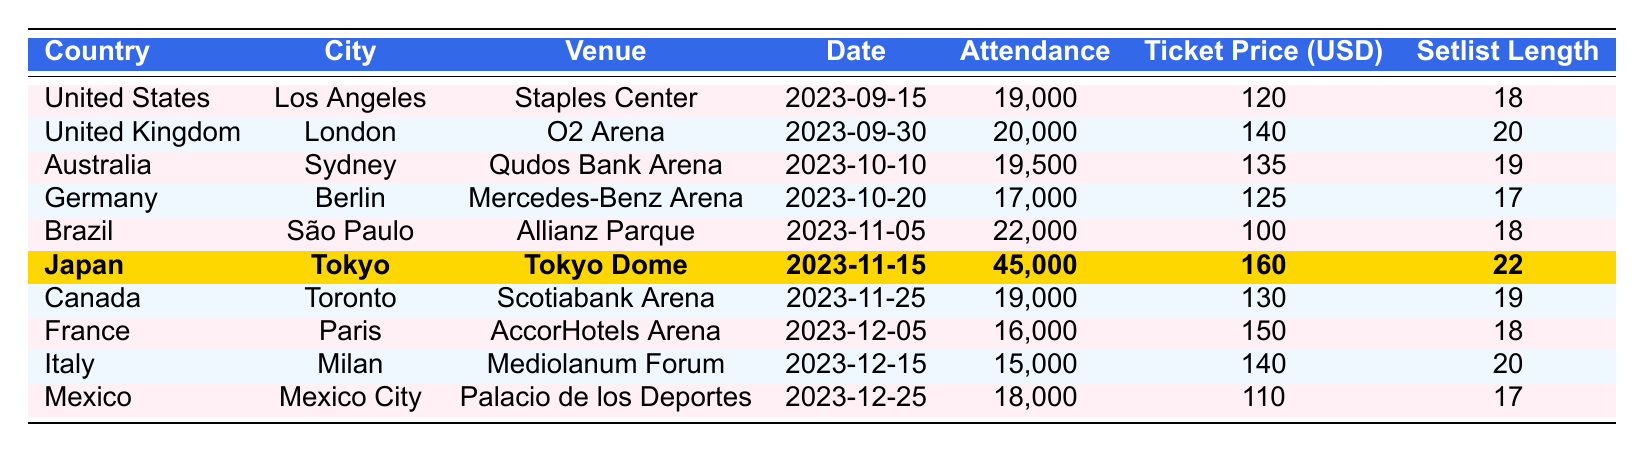What is the highest concert attendance for the Red Hot Chili Peppers tour? The table indicates that the highest attendance is from Japan at the Tokyo Dome with 45,000 attendees.
Answer: 45,000 What city in Canada hosted a Red Hot Chili Peppers concert? According to the table, the concert in Canada was held in Toronto.
Answer: Toronto How much was the ticket price in Brazil? The table shows that the ticket price in Brazil for the concert in São Paulo was 100 USD.
Answer: 100 Which country had the lowest concert attendance? By reviewing the attendance figures, France had the lowest with 16,000 attendees at the concert in Paris.
Answer: France What was the average ticket price for concerts in the United States and Canada? The ticket prices in the U.S. (120 USD) and Canada (130 USD) sum to 250 USD. Dividing by 2 gives an average ticket price of 125 USD.
Answer: 125 Did Japan's concert have the longest setlist? The table shows Japan with a setlist length of 22, which is the longest compared to other countries listed.
Answer: Yes What is the total attendance of all concerts held in countries with ticket prices above 130 USD? The countries with ticket prices above 130 USD are the United Kingdom (140 USD, 20,000 attendees), Australia (135 USD, 19,500 attendees), Japan (160 USD, 45,000 attendees), and France (150 USD, 16,000 attendees). Summing these gives: 20,000 + 19,500 + 45,000 + 16,000 = 100,500.
Answer: 100,500 How many concerts took place in Europe? The concerts in Europe took place in the United Kingdom (London), Germany (Berlin), France (Paris), and Italy (Milan), counting up to 4 concerts total.
Answer: 4 What is the difference in attendance between the concert in Japan and the concert in Mexico? Japan's attendance was 45,000 and Mexico's was 18,000. The difference is 45,000 - 18,000 = 27,000 attendees.
Answer: 27,000 Which country had the highest ticket price and what was it? The table indicates Japan had the highest ticket price at 160 USD.
Answer: Japan, 160 What percentage of the total attendance at concerts in Brazil and Germany does the attendance in Brazil represent? Brazil had 22,000 attendees and Germany had 17,000 attendees, for a total of 39,000. The percentage from Brazil is (22,000 / 39,000) * 100 = 56.41%.
Answer: 56.41% 